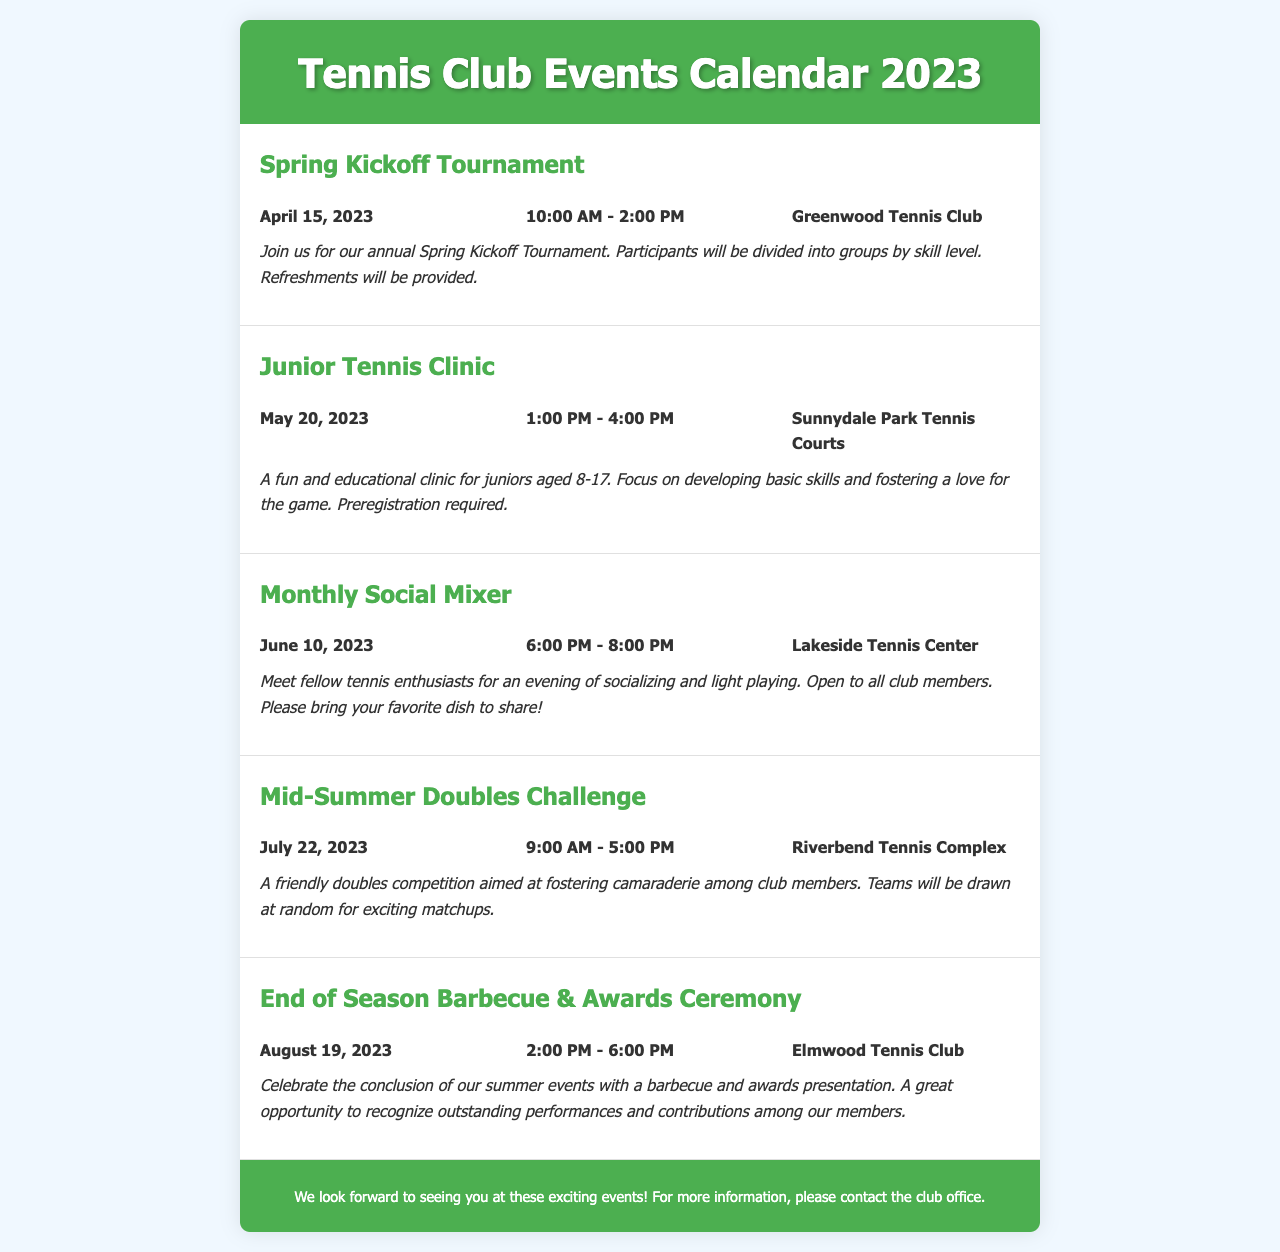What is the date of the Spring Kickoff Tournament? The document states that the Spring Kickoff Tournament is scheduled for April 15, 2023.
Answer: April 15, 2023 Where is the Junior Tennis Clinic held? According to the document, the location for the Junior Tennis Clinic is Sunnydale Park Tennis Courts.
Answer: Sunnydale Park Tennis Courts What time does the Monthly Social Mixer start? The document specifies that the Monthly Social Mixer begins at 6:00 PM.
Answer: 6:00 PM How many events are listed in the calendar? The document mentions five events: Spring Kickoff Tournament, Junior Tennis Clinic, Monthly Social Mixer, Mid-Summer Doubles Challenge, and End of Season Barbecue & Awards Ceremony.
Answer: Five What type of event is scheduled for August 19, 2023? The document describes the event scheduled for August 19, 2023, as an End of Season Barbecue & Awards Ceremony.
Answer: End of Season Barbecue & Awards Ceremony What is the purpose of the Mid-Summer Doubles Challenge? The document explains that the purpose of the Mid-Summer Doubles Challenge is to foster camaraderie among club members.
Answer: Foster camaraderie What should members bring to the Monthly Social Mixer? The document requests that attendees bring their favorite dish to share at the Monthly Social Mixer.
Answer: Favorite dish 